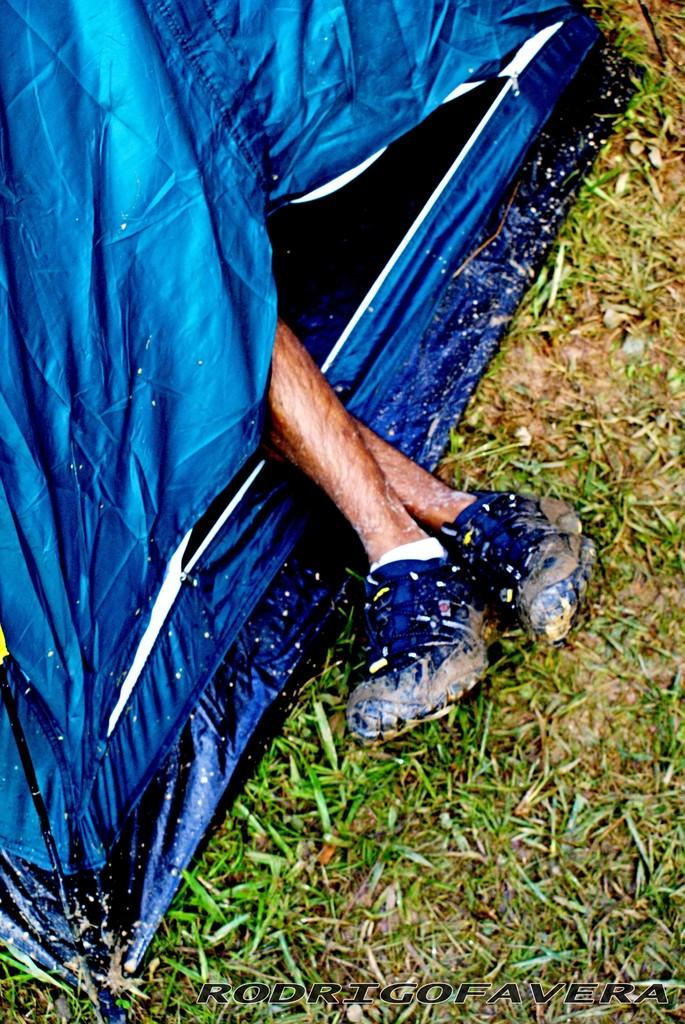What part of a person can be seen in the image? There are legs of a person in the image. What type of structure is visible in the image? There is a blue object that looks like a tent in the image. What is the ground covered with in the image? There is grass on the ground in the image. Is there any text present in the image? Yes, there is some text on the image. What type of toe is visible in the image? There is no toe visible in the image; only the legs of a person are shown. What kind of drug can be seen in the image? There is no drug present in the image. 